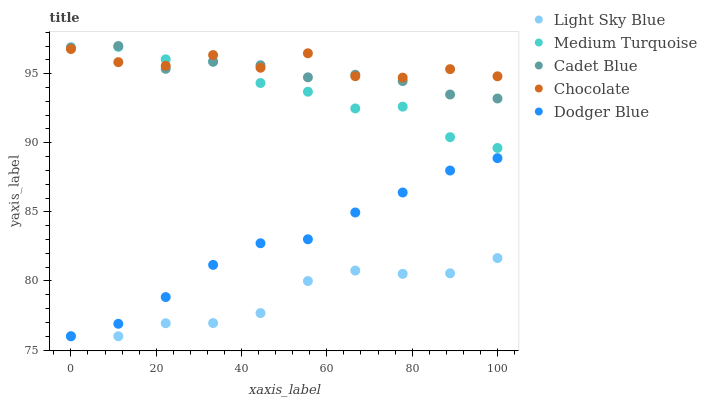Does Light Sky Blue have the minimum area under the curve?
Answer yes or no. Yes. Does Chocolate have the maximum area under the curve?
Answer yes or no. Yes. Does Dodger Blue have the minimum area under the curve?
Answer yes or no. No. Does Dodger Blue have the maximum area under the curve?
Answer yes or no. No. Is Dodger Blue the smoothest?
Answer yes or no. Yes. Is Chocolate the roughest?
Answer yes or no. Yes. Is Light Sky Blue the smoothest?
Answer yes or no. No. Is Light Sky Blue the roughest?
Answer yes or no. No. Does Light Sky Blue have the lowest value?
Answer yes or no. Yes. Does Medium Turquoise have the lowest value?
Answer yes or no. No. Does Cadet Blue have the highest value?
Answer yes or no. Yes. Does Dodger Blue have the highest value?
Answer yes or no. No. Is Light Sky Blue less than Cadet Blue?
Answer yes or no. Yes. Is Cadet Blue greater than Dodger Blue?
Answer yes or no. Yes. Does Chocolate intersect Medium Turquoise?
Answer yes or no. Yes. Is Chocolate less than Medium Turquoise?
Answer yes or no. No. Is Chocolate greater than Medium Turquoise?
Answer yes or no. No. Does Light Sky Blue intersect Cadet Blue?
Answer yes or no. No. 